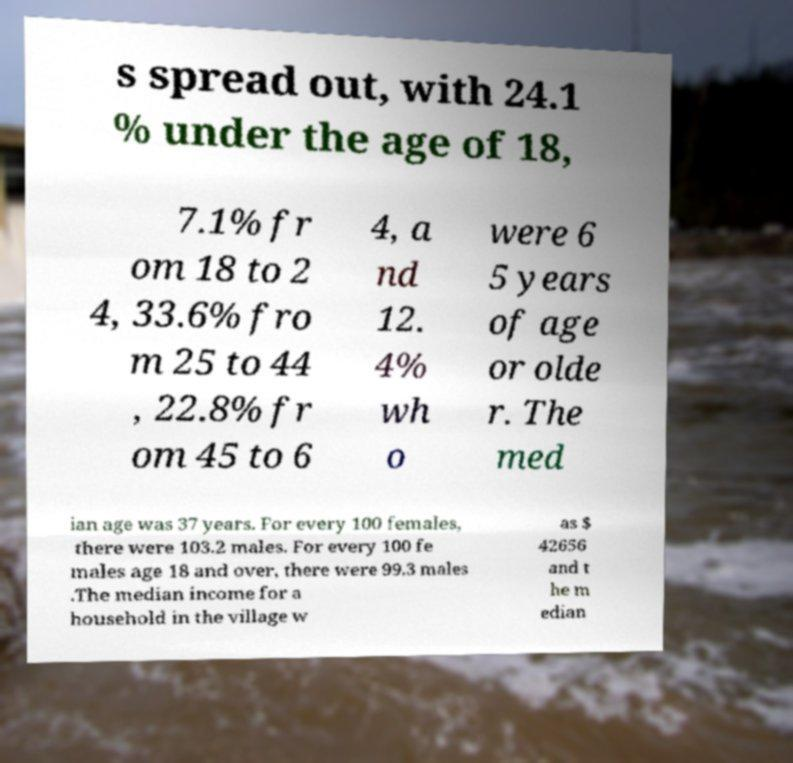For documentation purposes, I need the text within this image transcribed. Could you provide that? s spread out, with 24.1 % under the age of 18, 7.1% fr om 18 to 2 4, 33.6% fro m 25 to 44 , 22.8% fr om 45 to 6 4, a nd 12. 4% wh o were 6 5 years of age or olde r. The med ian age was 37 years. For every 100 females, there were 103.2 males. For every 100 fe males age 18 and over, there were 99.3 males .The median income for a household in the village w as $ 42656 and t he m edian 